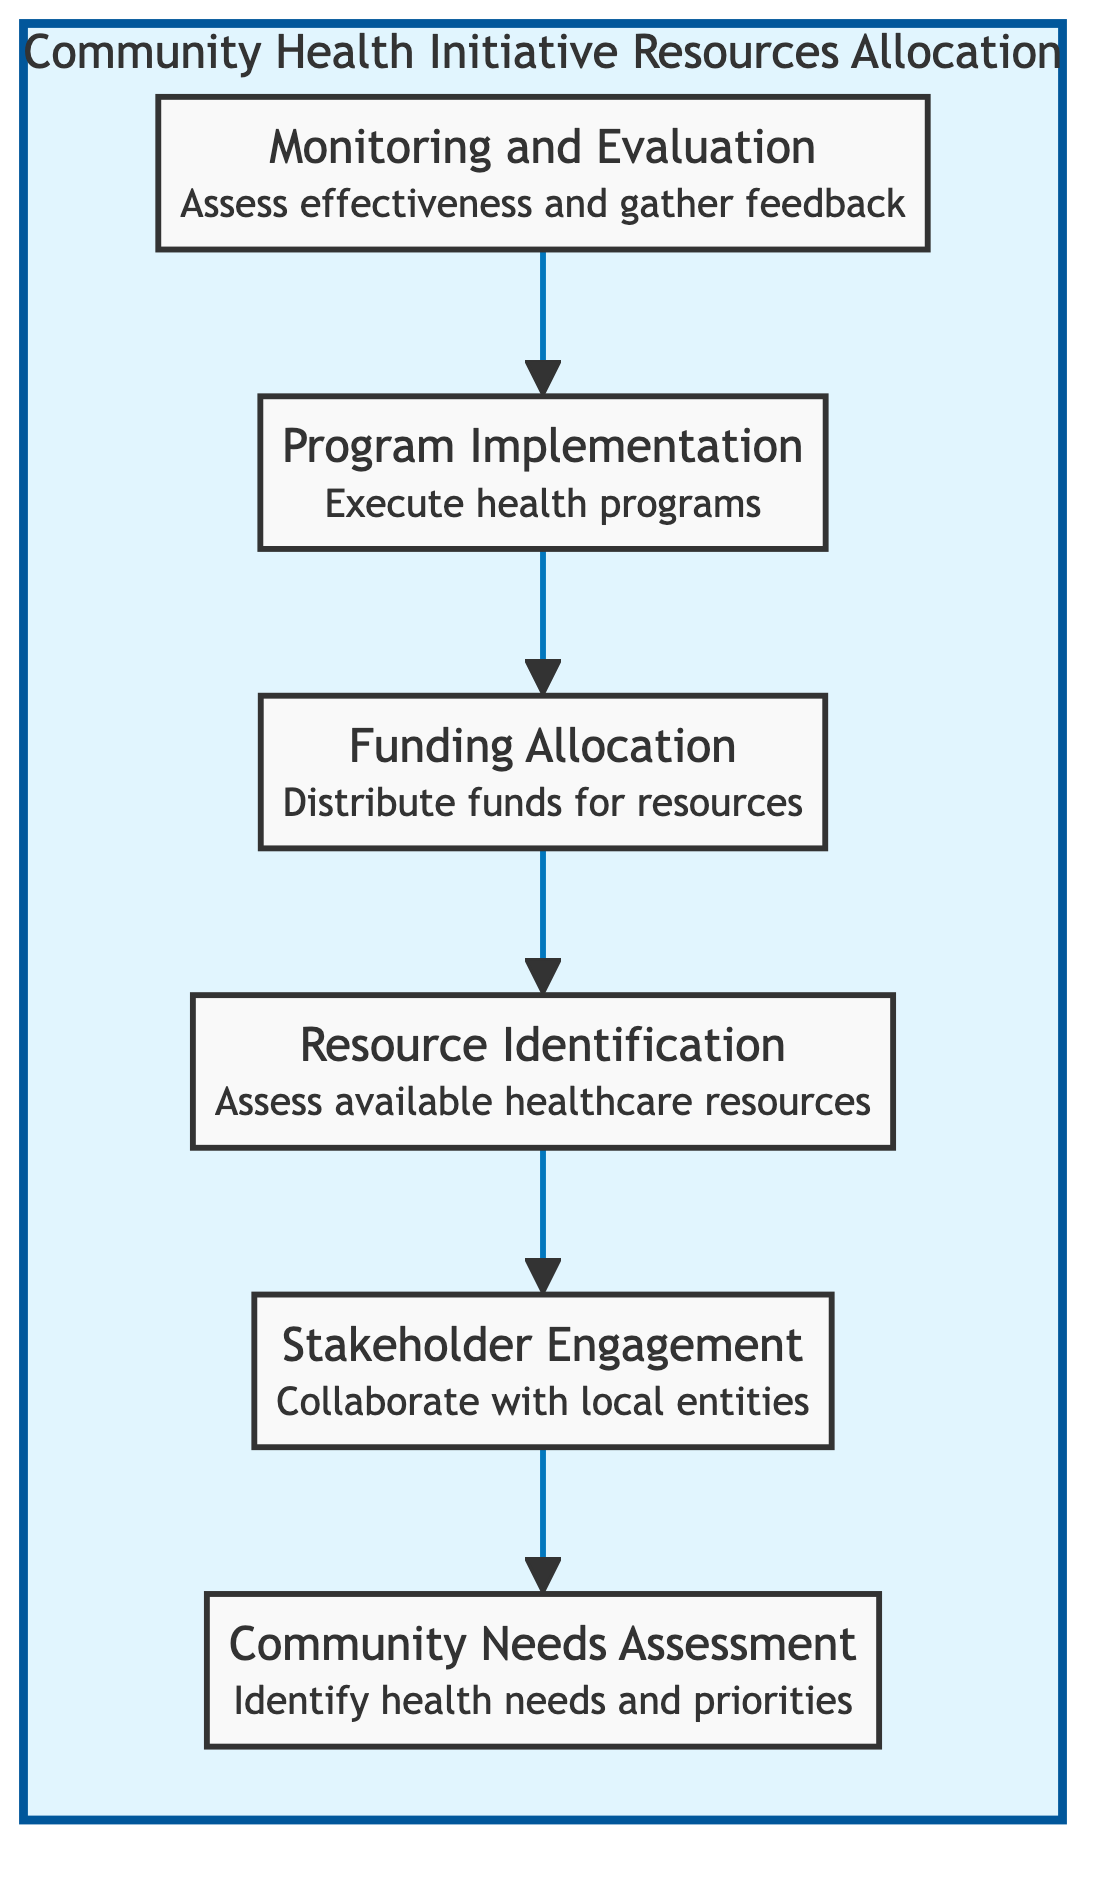What is the first step in the flow chart? The first step in the flow chart is the "Community Needs Assessment" which focuses on identifying health needs and priorities.
Answer: Community Needs Assessment How many nodes are present in the diagram? The diagram shows a total of six nodes that represent different stages in the resource allocation process.
Answer: 6 What follows "Funding Allocation" in the flow? After "Funding Allocation," the next step is "Resource Identification," indicating the need to assess available healthcare resources and facilities.
Answer: Resource Identification Which node involves collaboration with local entities? The "Stakeholder Engagement" node specifically highlights collaboration with local health workers, government bodies, and community leaders.
Answer: Stakeholder Engagement What is the last step after "Program Implementation"? The final step in the process is "Monitoring and Evaluation," which assesses the effectiveness of health initiatives and gathers feedback for improvement.
Answer: Monitoring and Evaluation Which two nodes are directly connected? "Monitoring and Evaluation" is directly connected to "Program Implementation," indicating that the assessment of effectiveness follows the execution of health programs.
Answer: Monitoring and Evaluation, Program Implementation If resources are identified, what is conducted immediately after? Once resources are identified, "Stakeholder Engagement" is conducted next, which involves collaborating with local entities to utilize the resources effectively.
Answer: Stakeholder Engagement Which node assesses the effectiveness of health initiatives? The "Monitoring and Evaluation" node focuses on assessing the effectiveness of health initiatives and gathering feedback for further improvement.
Answer: Monitoring and Evaluation Which node is at the base of the flow chart? At the bottom of the flow chart, "Community Needs Assessment" is positioned, indicating it's a foundational step in identifying the health needs and priorities.
Answer: Community Needs Assessment 